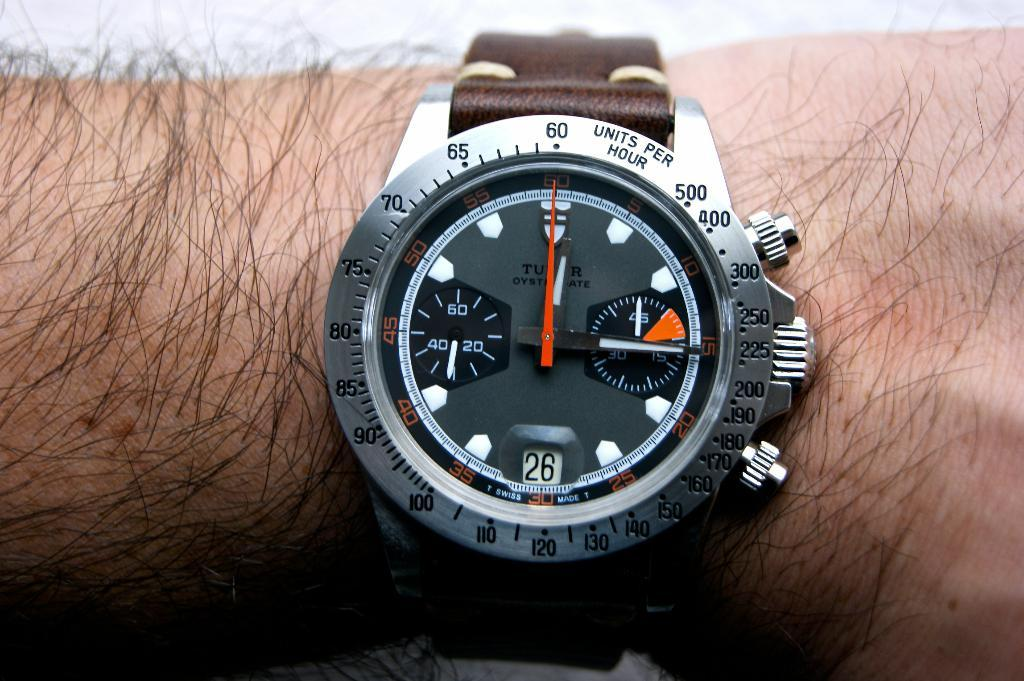<image>
Render a clear and concise summary of the photo. The watch on the man's arm is showing that it's the 26th day of the month. 